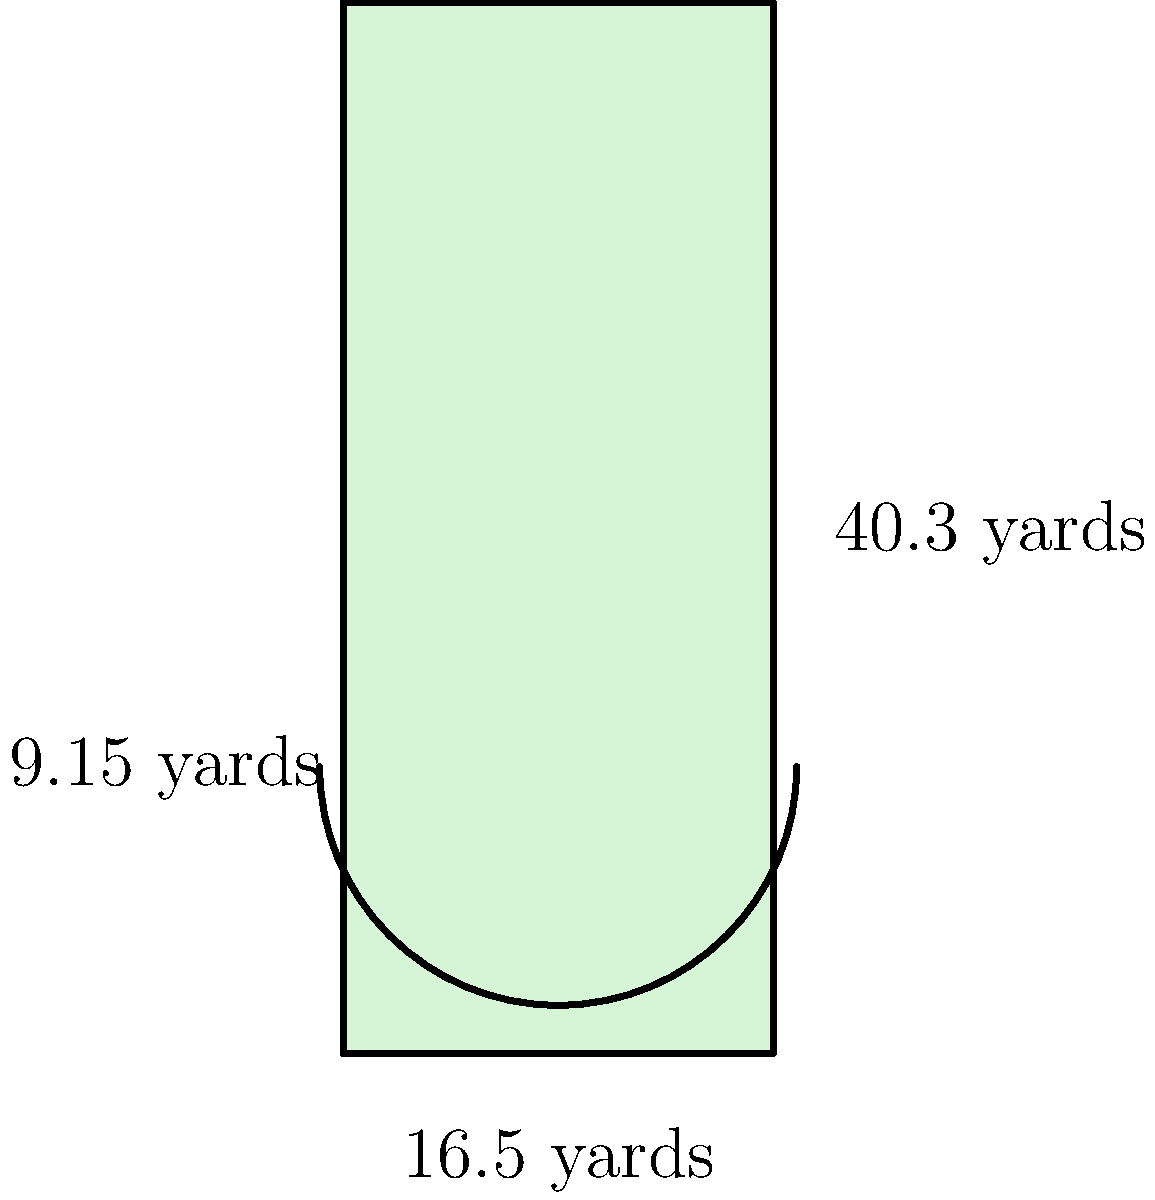At The Oval, home of Glentoran FC, you notice the penalty box dimensions. The width is 16.5 yards, and the length is 40.3 yards. There's also a semi-circular arc with a 9.15-yard radius at the top of the box. Calculate the total area of the penalty box in square yards, rounding your answer to the nearest whole number. Let's break this down step-by-step:

1) First, we need to calculate the area of the rectangular part of the penalty box:
   Area of rectangle = length × width
   $A_r = 40.3 \times 16.5 = 664.95$ square yards

2) Next, we need to calculate the area of the semi-circle:
   Area of a full circle = $\pi r^2$
   Area of semi-circle = $\frac{1}{2} \pi r^2$
   $A_s = \frac{1}{2} \times \pi \times 9.15^2 = 131.59$ square yards

3) The total area is the sum of these two areas:
   Total Area = Area of rectangle + Area of semi-circle
   $A_t = 664.95 + 131.59 = 796.54$ square yards

4) Rounding to the nearest whole number:
   $796.54 \approx 797$ square yards
Answer: 797 square yards 